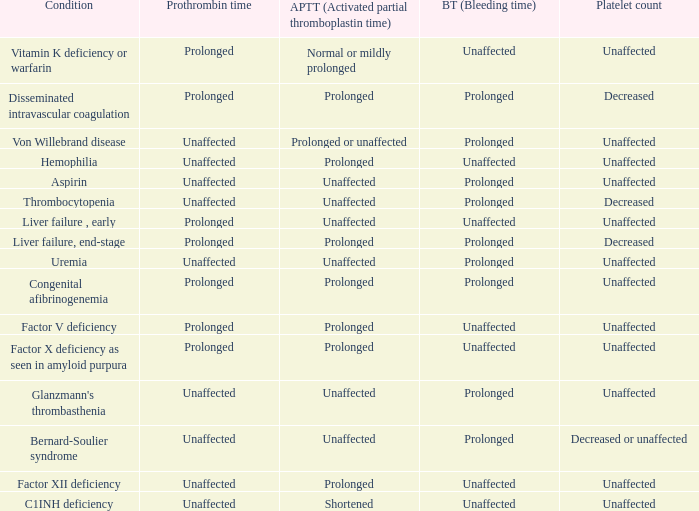What is hemophilia's bleeding time? Unaffected. 